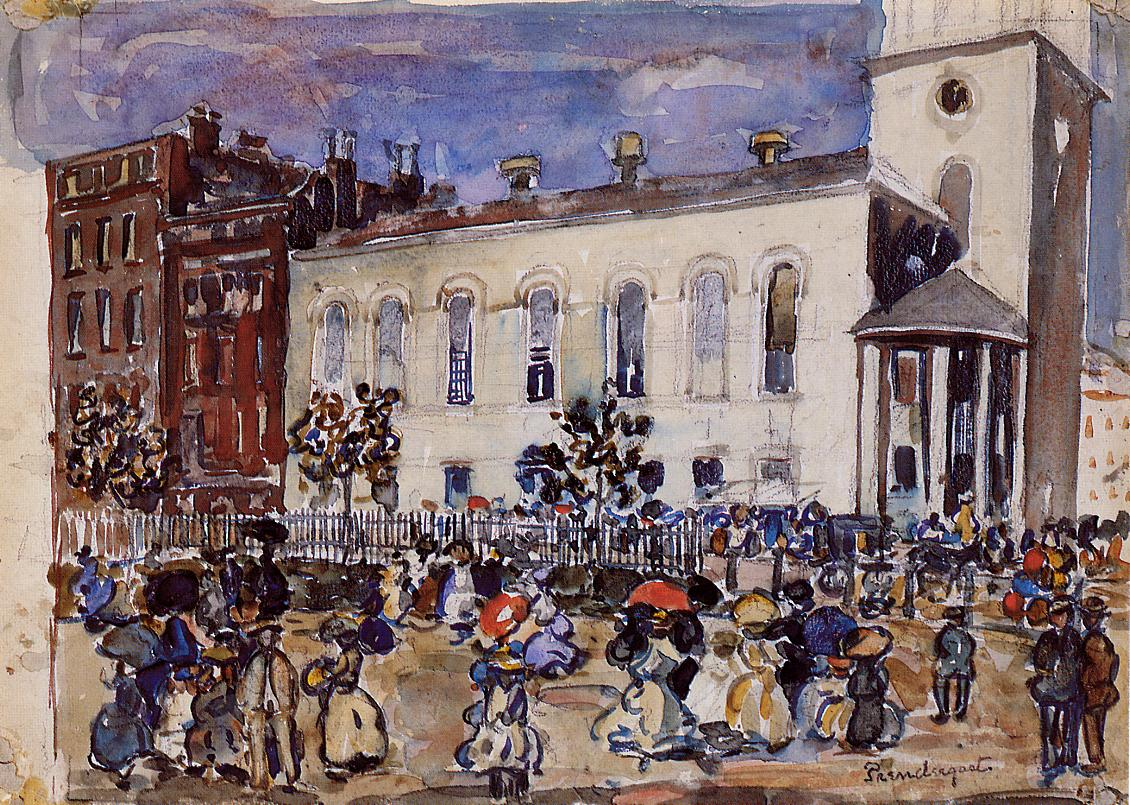What might the people in this scene be discussing or feeling? The figures in the painting likely encompass a range of emotions and topics of conversation. Judging from their body language and grouping, some might be engaging in casual small talk or exchanging news of the day. Others appear to be in a rush, perhaps conveying a sense of urgency or the fast-paced nature of city life. The children present add a layer of playfulness or curiosity. The interplay of shadows and light across the figures might reflect the fleeting moments of connection as people converge in a shared space, their tales and emotions as transient as the brushstrokes that depict them.  Can we deduce the time of year or day from the painting? The long shadows and warm tones suggest that the scene could be set in the late afternoon or early evening, a time when the sun casts elongated shadows and imbues the environment with a golden hue. Given the attire of the people, which includes hats and coats, it might be during a cooler season, possibly autumn or spring, when such clothing would be comfortable. The leaves visible on the trees do not appear lush, which could support the idea of it being during a transitional season rather than the peak of summer or the barrenness of winter. 